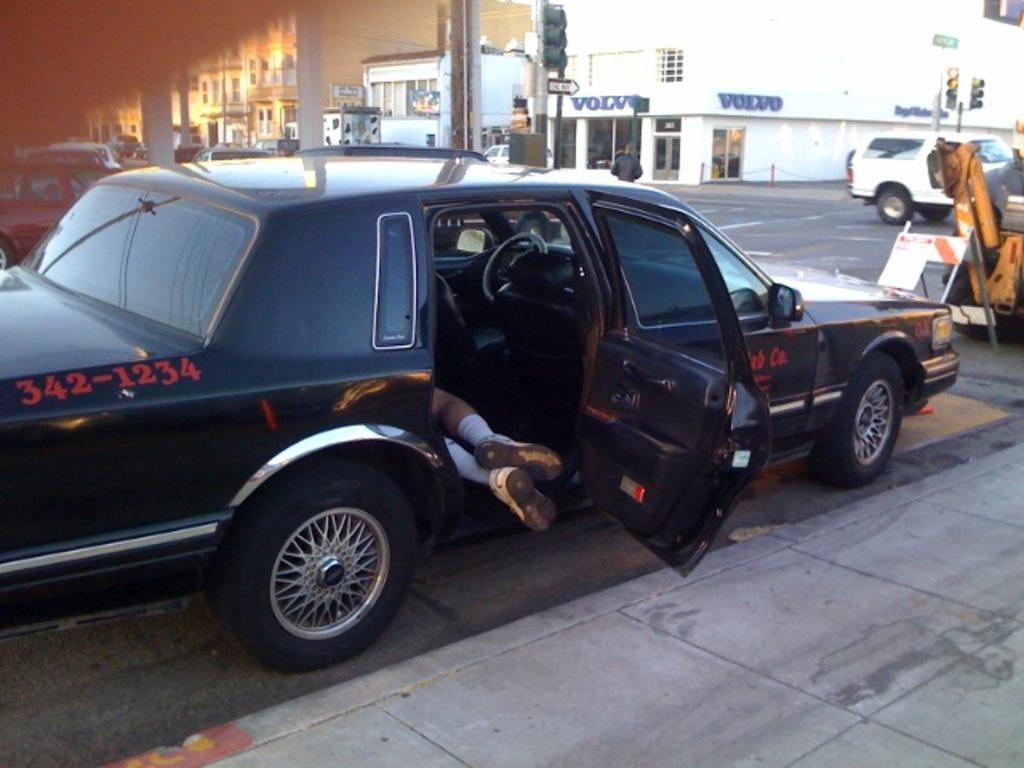Can you describe this image briefly? In this picture I can see the person's leg who is lying on the car's seat. In front of the car I can see the board and other vehicle. In the background I can see many buildings, street lights, traffic signals and road. In the top left I can see the sky. 